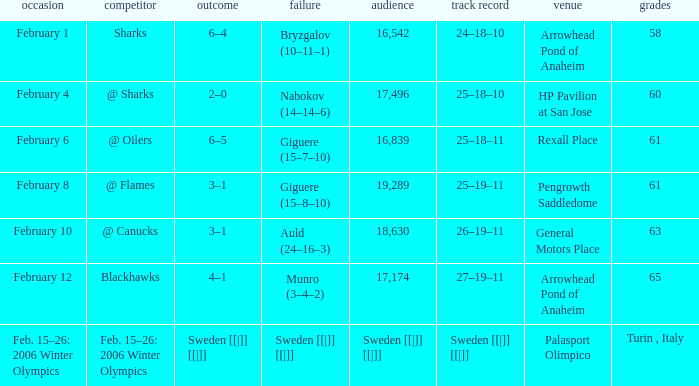What were the points on February 10? 63.0. 